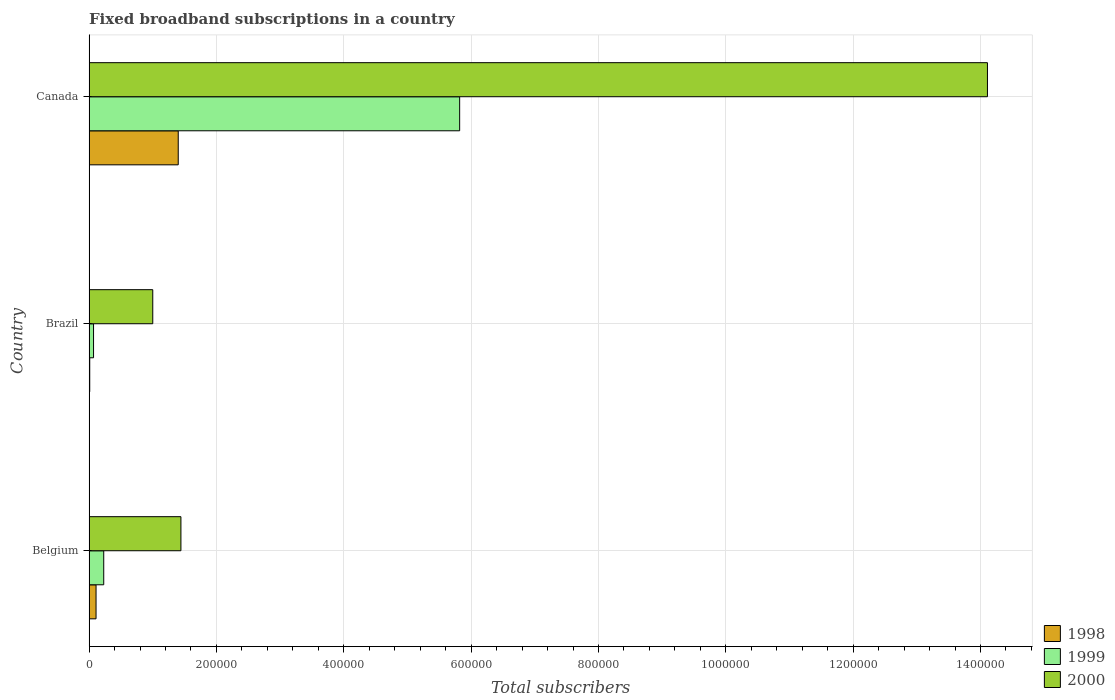How many different coloured bars are there?
Offer a very short reply. 3. How many groups of bars are there?
Your response must be concise. 3. How many bars are there on the 3rd tick from the top?
Provide a succinct answer. 3. What is the number of broadband subscriptions in 2000 in Belgium?
Provide a succinct answer. 1.44e+05. In which country was the number of broadband subscriptions in 1998 maximum?
Your answer should be compact. Canada. What is the total number of broadband subscriptions in 2000 in the graph?
Provide a succinct answer. 1.66e+06. What is the difference between the number of broadband subscriptions in 2000 in Belgium and that in Brazil?
Your response must be concise. 4.42e+04. What is the difference between the number of broadband subscriptions in 2000 in Canada and the number of broadband subscriptions in 1998 in Belgium?
Keep it short and to the point. 1.40e+06. What is the average number of broadband subscriptions in 2000 per country?
Your answer should be compact. 5.52e+05. What is the difference between the number of broadband subscriptions in 2000 and number of broadband subscriptions in 1998 in Brazil?
Ensure brevity in your answer.  9.90e+04. What is the ratio of the number of broadband subscriptions in 1999 in Brazil to that in Canada?
Offer a very short reply. 0.01. What is the difference between the highest and the second highest number of broadband subscriptions in 1998?
Your answer should be compact. 1.29e+05. What is the difference between the highest and the lowest number of broadband subscriptions in 1999?
Provide a short and direct response. 5.75e+05. In how many countries, is the number of broadband subscriptions in 1999 greater than the average number of broadband subscriptions in 1999 taken over all countries?
Provide a short and direct response. 1. How many bars are there?
Your answer should be compact. 9. Are all the bars in the graph horizontal?
Give a very brief answer. Yes. How many countries are there in the graph?
Provide a short and direct response. 3. What is the difference between two consecutive major ticks on the X-axis?
Ensure brevity in your answer.  2.00e+05. Does the graph contain grids?
Give a very brief answer. Yes. Where does the legend appear in the graph?
Ensure brevity in your answer.  Bottom right. What is the title of the graph?
Ensure brevity in your answer.  Fixed broadband subscriptions in a country. What is the label or title of the X-axis?
Provide a short and direct response. Total subscribers. What is the Total subscribers in 1998 in Belgium?
Keep it short and to the point. 1.09e+04. What is the Total subscribers in 1999 in Belgium?
Keep it short and to the point. 2.30e+04. What is the Total subscribers in 2000 in Belgium?
Give a very brief answer. 1.44e+05. What is the Total subscribers in 1998 in Brazil?
Offer a very short reply. 1000. What is the Total subscribers in 1999 in Brazil?
Provide a short and direct response. 7000. What is the Total subscribers in 2000 in Brazil?
Your answer should be very brief. 1.00e+05. What is the Total subscribers of 1998 in Canada?
Your response must be concise. 1.40e+05. What is the Total subscribers in 1999 in Canada?
Your answer should be compact. 5.82e+05. What is the Total subscribers of 2000 in Canada?
Provide a succinct answer. 1.41e+06. Across all countries, what is the maximum Total subscribers of 1998?
Offer a terse response. 1.40e+05. Across all countries, what is the maximum Total subscribers in 1999?
Keep it short and to the point. 5.82e+05. Across all countries, what is the maximum Total subscribers in 2000?
Your answer should be compact. 1.41e+06. Across all countries, what is the minimum Total subscribers of 1998?
Provide a succinct answer. 1000. Across all countries, what is the minimum Total subscribers in 1999?
Your response must be concise. 7000. Across all countries, what is the minimum Total subscribers of 2000?
Your answer should be very brief. 1.00e+05. What is the total Total subscribers in 1998 in the graph?
Give a very brief answer. 1.52e+05. What is the total Total subscribers of 1999 in the graph?
Your answer should be compact. 6.12e+05. What is the total Total subscribers of 2000 in the graph?
Make the answer very short. 1.66e+06. What is the difference between the Total subscribers of 1998 in Belgium and that in Brazil?
Your response must be concise. 9924. What is the difference between the Total subscribers in 1999 in Belgium and that in Brazil?
Provide a succinct answer. 1.60e+04. What is the difference between the Total subscribers of 2000 in Belgium and that in Brazil?
Provide a short and direct response. 4.42e+04. What is the difference between the Total subscribers of 1998 in Belgium and that in Canada?
Offer a very short reply. -1.29e+05. What is the difference between the Total subscribers in 1999 in Belgium and that in Canada?
Give a very brief answer. -5.59e+05. What is the difference between the Total subscribers of 2000 in Belgium and that in Canada?
Offer a very short reply. -1.27e+06. What is the difference between the Total subscribers of 1998 in Brazil and that in Canada?
Give a very brief answer. -1.39e+05. What is the difference between the Total subscribers in 1999 in Brazil and that in Canada?
Offer a very short reply. -5.75e+05. What is the difference between the Total subscribers of 2000 in Brazil and that in Canada?
Your answer should be very brief. -1.31e+06. What is the difference between the Total subscribers of 1998 in Belgium and the Total subscribers of 1999 in Brazil?
Offer a terse response. 3924. What is the difference between the Total subscribers in 1998 in Belgium and the Total subscribers in 2000 in Brazil?
Provide a short and direct response. -8.91e+04. What is the difference between the Total subscribers of 1999 in Belgium and the Total subscribers of 2000 in Brazil?
Make the answer very short. -7.70e+04. What is the difference between the Total subscribers in 1998 in Belgium and the Total subscribers in 1999 in Canada?
Offer a very short reply. -5.71e+05. What is the difference between the Total subscribers in 1998 in Belgium and the Total subscribers in 2000 in Canada?
Ensure brevity in your answer.  -1.40e+06. What is the difference between the Total subscribers in 1999 in Belgium and the Total subscribers in 2000 in Canada?
Your response must be concise. -1.39e+06. What is the difference between the Total subscribers of 1998 in Brazil and the Total subscribers of 1999 in Canada?
Provide a short and direct response. -5.81e+05. What is the difference between the Total subscribers of 1998 in Brazil and the Total subscribers of 2000 in Canada?
Keep it short and to the point. -1.41e+06. What is the difference between the Total subscribers of 1999 in Brazil and the Total subscribers of 2000 in Canada?
Your response must be concise. -1.40e+06. What is the average Total subscribers in 1998 per country?
Offer a very short reply. 5.06e+04. What is the average Total subscribers of 1999 per country?
Provide a short and direct response. 2.04e+05. What is the average Total subscribers of 2000 per country?
Your answer should be compact. 5.52e+05. What is the difference between the Total subscribers of 1998 and Total subscribers of 1999 in Belgium?
Offer a very short reply. -1.21e+04. What is the difference between the Total subscribers in 1998 and Total subscribers in 2000 in Belgium?
Make the answer very short. -1.33e+05. What is the difference between the Total subscribers of 1999 and Total subscribers of 2000 in Belgium?
Offer a terse response. -1.21e+05. What is the difference between the Total subscribers of 1998 and Total subscribers of 1999 in Brazil?
Make the answer very short. -6000. What is the difference between the Total subscribers of 1998 and Total subscribers of 2000 in Brazil?
Your answer should be very brief. -9.90e+04. What is the difference between the Total subscribers of 1999 and Total subscribers of 2000 in Brazil?
Your answer should be very brief. -9.30e+04. What is the difference between the Total subscribers in 1998 and Total subscribers in 1999 in Canada?
Offer a very short reply. -4.42e+05. What is the difference between the Total subscribers of 1998 and Total subscribers of 2000 in Canada?
Offer a very short reply. -1.27e+06. What is the difference between the Total subscribers in 1999 and Total subscribers in 2000 in Canada?
Your answer should be very brief. -8.29e+05. What is the ratio of the Total subscribers in 1998 in Belgium to that in Brazil?
Ensure brevity in your answer.  10.92. What is the ratio of the Total subscribers of 1999 in Belgium to that in Brazil?
Make the answer very short. 3.29. What is the ratio of the Total subscribers of 2000 in Belgium to that in Brazil?
Your response must be concise. 1.44. What is the ratio of the Total subscribers of 1998 in Belgium to that in Canada?
Offer a terse response. 0.08. What is the ratio of the Total subscribers of 1999 in Belgium to that in Canada?
Offer a terse response. 0.04. What is the ratio of the Total subscribers in 2000 in Belgium to that in Canada?
Provide a succinct answer. 0.1. What is the ratio of the Total subscribers in 1998 in Brazil to that in Canada?
Give a very brief answer. 0.01. What is the ratio of the Total subscribers of 1999 in Brazil to that in Canada?
Offer a terse response. 0.01. What is the ratio of the Total subscribers in 2000 in Brazil to that in Canada?
Give a very brief answer. 0.07. What is the difference between the highest and the second highest Total subscribers of 1998?
Offer a terse response. 1.29e+05. What is the difference between the highest and the second highest Total subscribers of 1999?
Ensure brevity in your answer.  5.59e+05. What is the difference between the highest and the second highest Total subscribers in 2000?
Your answer should be compact. 1.27e+06. What is the difference between the highest and the lowest Total subscribers of 1998?
Your response must be concise. 1.39e+05. What is the difference between the highest and the lowest Total subscribers in 1999?
Offer a terse response. 5.75e+05. What is the difference between the highest and the lowest Total subscribers of 2000?
Your response must be concise. 1.31e+06. 